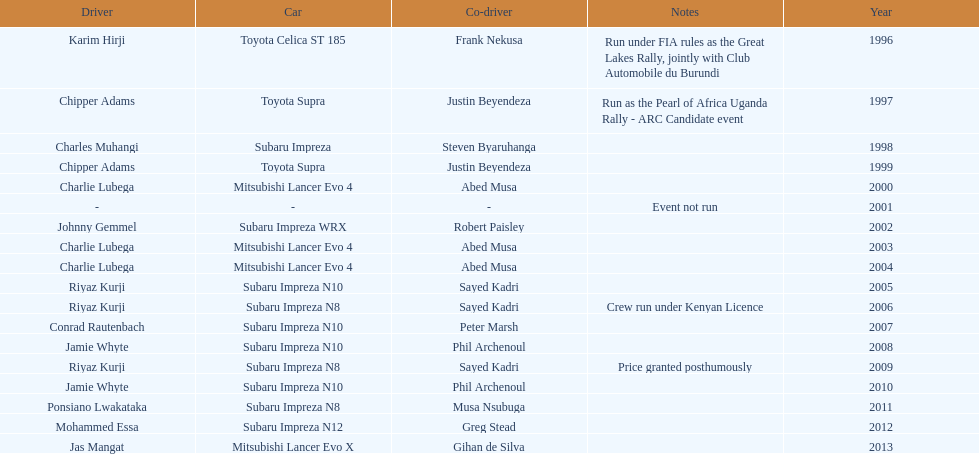Chipper adams and justin beyendeza have how mnay wins? 2. 